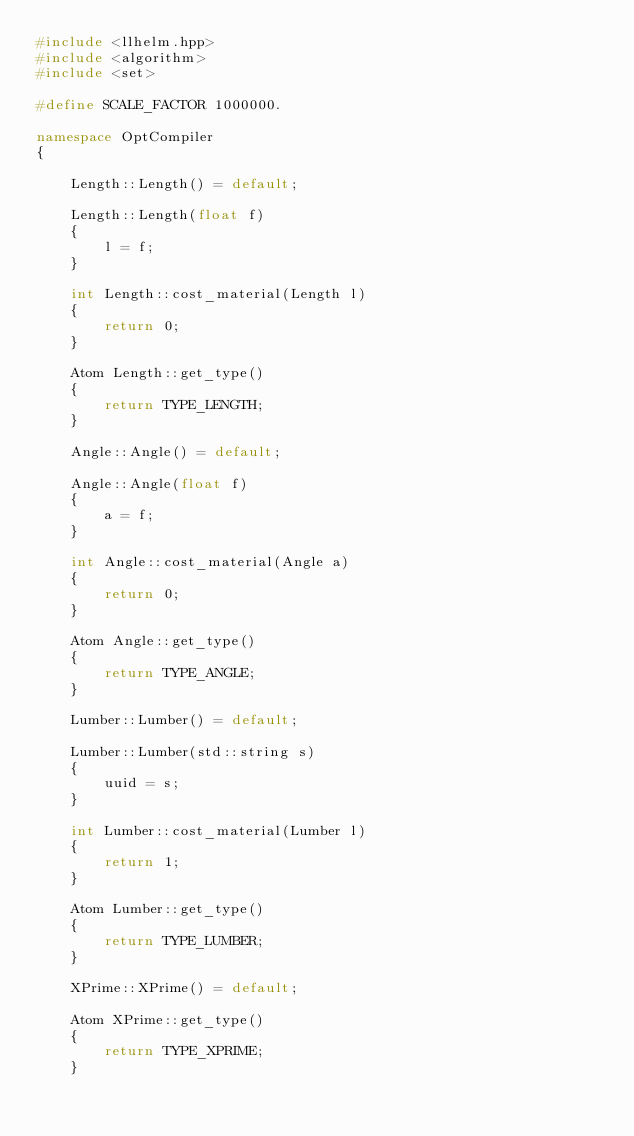Convert code to text. <code><loc_0><loc_0><loc_500><loc_500><_C++_>#include <llhelm.hpp>
#include <algorithm>
#include <set>

#define SCALE_FACTOR 1000000.

namespace OptCompiler
{

	Length::Length() = default;

	Length::Length(float f)
	{
		l = f;
	}

	int Length::cost_material(Length l)
	{
		return 0;
	}

	Atom Length::get_type()
	{
		return TYPE_LENGTH;
	}

	Angle::Angle() = default;

	Angle::Angle(float f)
	{
		a = f;
	}

	int Angle::cost_material(Angle a)
	{
		return 0;
	}

	Atom Angle::get_type()
	{
		return TYPE_ANGLE;
	}

	Lumber::Lumber() = default;

	Lumber::Lumber(std::string s)
	{
		uuid = s;
	}

	int Lumber::cost_material(Lumber l)
	{
		return 1;
	}

	Atom Lumber::get_type()
	{
		return TYPE_LUMBER;
	}

	XPrime::XPrime() = default;

	Atom XPrime::get_type()
	{
		return TYPE_XPRIME;
	}
</code> 